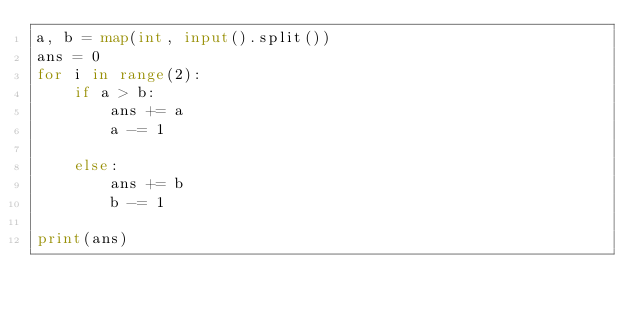<code> <loc_0><loc_0><loc_500><loc_500><_Python_>a, b = map(int, input().split())
ans = 0
for i in range(2):
    if a > b:
        ans += a
        a -= 1
    
    else:
        ans += b
        b -= 1
    
print(ans)</code> 